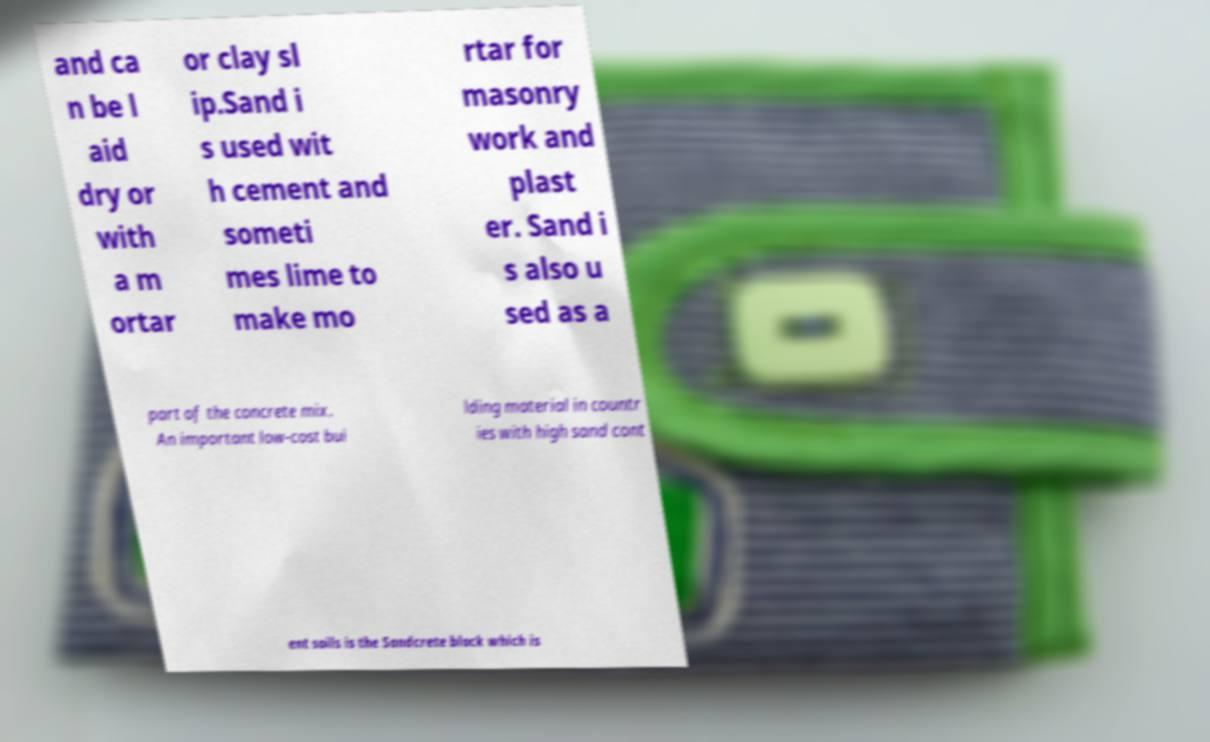For documentation purposes, I need the text within this image transcribed. Could you provide that? and ca n be l aid dry or with a m ortar or clay sl ip.Sand i s used wit h cement and someti mes lime to make mo rtar for masonry work and plast er. Sand i s also u sed as a part of the concrete mix. An important low-cost bui lding material in countr ies with high sand cont ent soils is the Sandcrete block which is 